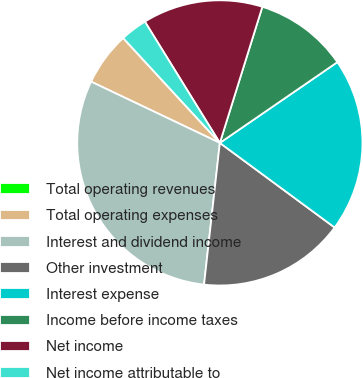<chart> <loc_0><loc_0><loc_500><loc_500><pie_chart><fcel>Total operating revenues<fcel>Total operating expenses<fcel>Interest and dividend income<fcel>Other investment<fcel>Interest expense<fcel>Income before income taxes<fcel>Net income<fcel>Net income attributable to<nl><fcel>0.01%<fcel>6.07%<fcel>30.3%<fcel>16.66%<fcel>19.69%<fcel>10.6%<fcel>13.63%<fcel>3.04%<nl></chart> 